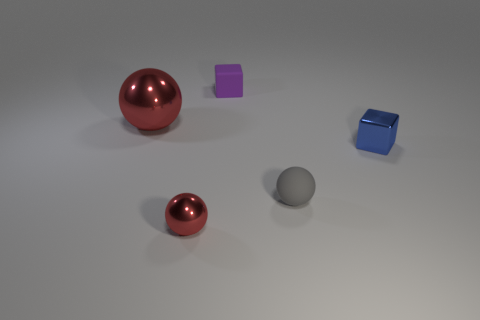There is another metal sphere that is the same color as the big ball; what is its size?
Your answer should be compact. Small. What number of metallic balls are in front of the tiny gray matte ball and on the left side of the small red metallic ball?
Make the answer very short. 0. There is a sphere that is behind the blue metallic block; what number of metallic spheres are in front of it?
Your response must be concise. 1. How many things are either tiny spheres that are left of the gray rubber ball or metallic objects in front of the small gray matte object?
Your response must be concise. 1. There is a small purple object that is the same shape as the tiny blue shiny object; what material is it?
Make the answer very short. Rubber. What number of objects are rubber objects that are behind the tiny matte sphere or metallic blocks?
Offer a very short reply. 2. What is the shape of the thing that is made of the same material as the small purple block?
Your answer should be compact. Sphere. What number of other tiny matte things have the same shape as the gray object?
Your answer should be compact. 0. What is the material of the blue object?
Ensure brevity in your answer.  Metal. Is the color of the metallic block the same as the small sphere that is on the left side of the small gray object?
Give a very brief answer. No. 